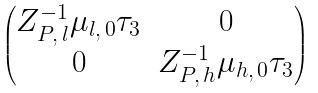Convert formula to latex. <formula><loc_0><loc_0><loc_500><loc_500>\begin{pmatrix} Z _ { P , \, l } ^ { - 1 } \mu _ { l , \, 0 } \tau _ { 3 } & 0 \\ 0 & Z _ { P , \, h } ^ { - 1 } \mu _ { h , \, 0 } \tau _ { 3 } \end{pmatrix}</formula> 